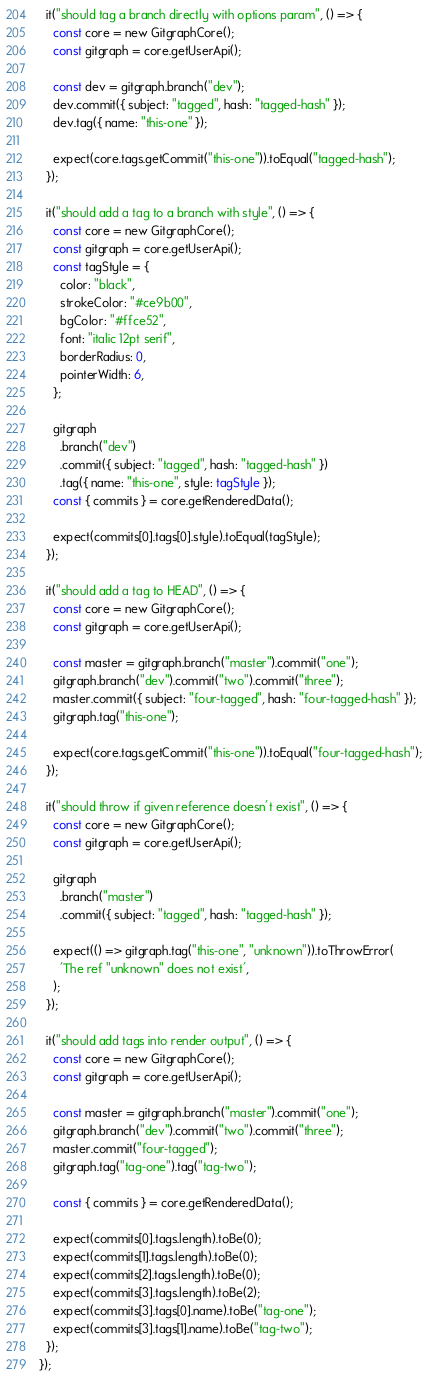<code> <loc_0><loc_0><loc_500><loc_500><_TypeScript_>
  it("should tag a branch directly with options param", () => {
    const core = new GitgraphCore();
    const gitgraph = core.getUserApi();

    const dev = gitgraph.branch("dev");
    dev.commit({ subject: "tagged", hash: "tagged-hash" });
    dev.tag({ name: "this-one" });

    expect(core.tags.getCommit("this-one")).toEqual("tagged-hash");
  });

  it("should add a tag to a branch with style", () => {
    const core = new GitgraphCore();
    const gitgraph = core.getUserApi();
    const tagStyle = {
      color: "black",
      strokeColor: "#ce9b00",
      bgColor: "#ffce52",
      font: "italic 12pt serif",
      borderRadius: 0,
      pointerWidth: 6,
    };

    gitgraph
      .branch("dev")
      .commit({ subject: "tagged", hash: "tagged-hash" })
      .tag({ name: "this-one", style: tagStyle });
    const { commits } = core.getRenderedData();

    expect(commits[0].tags[0].style).toEqual(tagStyle);
  });

  it("should add a tag to HEAD", () => {
    const core = new GitgraphCore();
    const gitgraph = core.getUserApi();

    const master = gitgraph.branch("master").commit("one");
    gitgraph.branch("dev").commit("two").commit("three");
    master.commit({ subject: "four-tagged", hash: "four-tagged-hash" });
    gitgraph.tag("this-one");

    expect(core.tags.getCommit("this-one")).toEqual("four-tagged-hash");
  });

  it("should throw if given reference doesn't exist", () => {
    const core = new GitgraphCore();
    const gitgraph = core.getUserApi();

    gitgraph
      .branch("master")
      .commit({ subject: "tagged", hash: "tagged-hash" });

    expect(() => gitgraph.tag("this-one", "unknown")).toThrowError(
      'The ref "unknown" does not exist',
    );
  });

  it("should add tags into render output", () => {
    const core = new GitgraphCore();
    const gitgraph = core.getUserApi();

    const master = gitgraph.branch("master").commit("one");
    gitgraph.branch("dev").commit("two").commit("three");
    master.commit("four-tagged");
    gitgraph.tag("tag-one").tag("tag-two");

    const { commits } = core.getRenderedData();

    expect(commits[0].tags.length).toBe(0);
    expect(commits[1].tags.length).toBe(0);
    expect(commits[2].tags.length).toBe(0);
    expect(commits[3].tags.length).toBe(2);
    expect(commits[3].tags[0].name).toBe("tag-one");
    expect(commits[3].tags[1].name).toBe("tag-two");
  });
});
</code> 